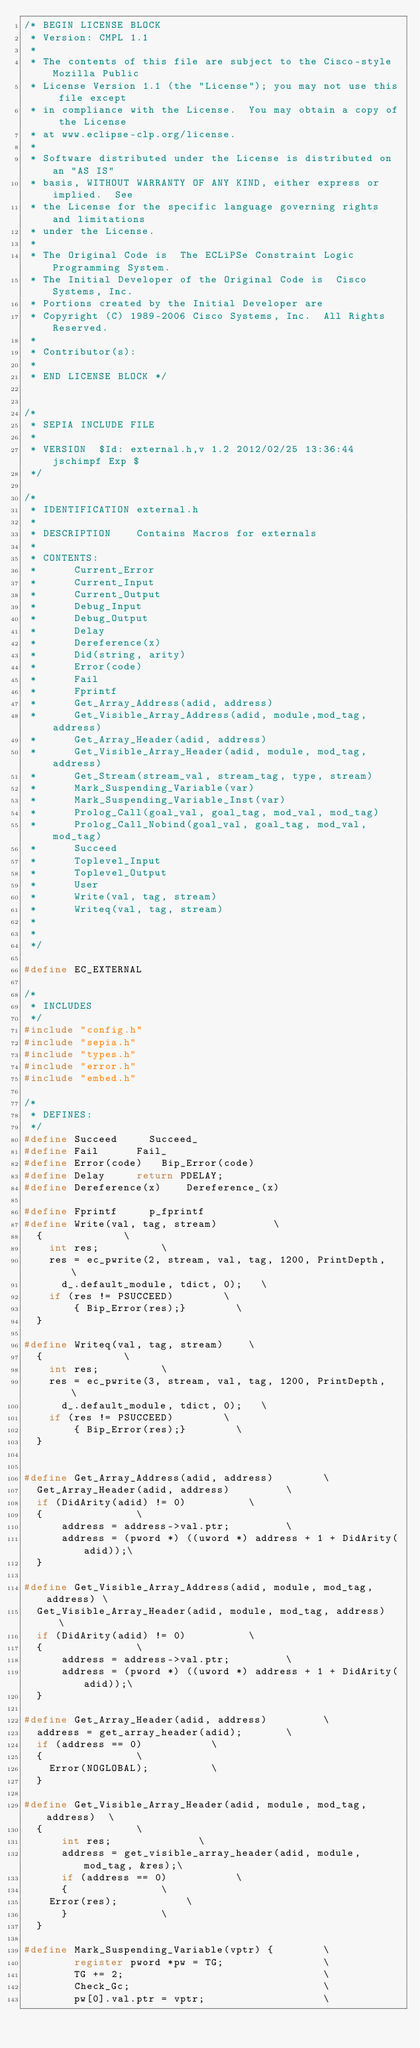<code> <loc_0><loc_0><loc_500><loc_500><_C_>/* BEGIN LICENSE BLOCK
 * Version: CMPL 1.1
 *
 * The contents of this file are subject to the Cisco-style Mozilla Public
 * License Version 1.1 (the "License"); you may not use this file except
 * in compliance with the License.  You may obtain a copy of the License
 * at www.eclipse-clp.org/license.
 * 
 * Software distributed under the License is distributed on an "AS IS"
 * basis, WITHOUT WARRANTY OF ANY KIND, either express or implied.  See
 * the License for the specific language governing rights and limitations
 * under the License. 
 * 
 * The Original Code is  The ECLiPSe Constraint Logic Programming System. 
 * The Initial Developer of the Original Code is  Cisco Systems, Inc. 
 * Portions created by the Initial Developer are
 * Copyright (C) 1989-2006 Cisco Systems, Inc.  All Rights Reserved.
 * 
 * Contributor(s): 
 * 
 * END LICENSE BLOCK */


/*
 * SEPIA INCLUDE FILE
 *
 * VERSION	$Id: external.h,v 1.2 2012/02/25 13:36:44 jschimpf Exp $
 */

/*
 * IDENTIFICATION	external.h
 *
 * DESCRIPTION   	Contains Macros for externals 
 *       
 * CONTENTS:
 *			Current_Error 
 *			Current_Input  
 *			Current_Output 
 *			Debug_Input
 *			Debug_Output 
 *			Delay     
 *			Dereference(x) 
 *			Did(string, arity)  
 *			Error(code)  
 *			Fail  
 *			Fprintf  
 *			Get_Array_Address(adid, address)
 *			Get_Visible_Array_Address(adid, module,mod_tag,address)
 *			Get_Array_Header(adid, address)  
 *			Get_Visible_Array_Header(adid, module, mod_tag,address)
 *			Get_Stream(stream_val, stream_tag, type, stream)
 *			Mark_Suspending_Variable(var)
 *			Mark_Suspending_Variable_Inst(var)
 *			Prolog_Call(goal_val, goal_tag, mod_val, mod_tag)
 *			Prolog_Call_Nobind(goal_val, goal_tag, mod_val, mod_tag)
 *			Succeed  
 *			Toplevel_Input  
 *			Toplevel_Output  
 *			User 
 *			Write(val, tag, stream)  
 *			Writeq(val, tag, stream) 
 *
 *
 */

#define EC_EXTERNAL

/*
 * INCLUDES
 */
#include "config.h"
#include "sepia.h"
#include "types.h"
#include "error.h"
#include "embed.h"

/*
 * DEFINES:
 */
#define	Succeed			Succeed_
#define Fail			Fail_
#define Error(code)		Bip_Error(code)
#define Delay			return PDELAY;
#define Dereference(x)		Dereference_(x)

#define Fprintf			p_fprintf
#define Write(val, tag, stream)					\
	{							\
		int	res;					\
		res = ec_pwrite(2, stream, val, tag, 1200, PrintDepth,	\
			d_.default_module, tdict, 0);		\
		if (res != PSUCCEED)				\
		    { Bip_Error(res);}				\
	}

#define Writeq(val, tag, stream)		\
	{							\
		int	res;					\
		res = ec_pwrite(3, stream, val, tag, 1200, PrintDepth,	\
			d_.default_module, tdict, 0);		\
		if (res != PSUCCEED)				\
		    { Bip_Error(res);}				\
	}


#define Get_Array_Address(adid, address)				\
	Get_Array_Header(adid, address)					\
	if (DidArity(adid) != 0)					\
	{								\
	    address = address->val.ptr;					\
	    address = (pword *) ((uword *) address + 1 + DidArity(adid));\
	}

#define Get_Visible_Array_Address(adid, module, mod_tag, address)	\
	Get_Visible_Array_Header(adid, module, mod_tag, address)	\
	if (DidArity(adid) != 0)					\
	{								\
	    address = address->val.ptr;					\
	    address = (pword *) ((uword *) address + 1 + DidArity(adid));\
	}

#define Get_Array_Header(adid, address)					\
	address = get_array_header(adid);				\
	if (address == 0)						\
	{								\
		Error(NOGLOBAL);					\
	}

#define Get_Visible_Array_Header(adid, module, mod_tag, address)	\
	{								\
	    int	res;							\
	    address = get_visible_array_header(adid, module, mod_tag, &res);\
	    if (address == 0)						\
	    {								\
		Error(res);						\
	    }								\
	}

#define Mark_Suspending_Variable(vptr) {        \
        register pword *pw = TG;                \
        TG += 2;                                \
        Check_Gc;                               \
        pw[0].val.ptr = vptr;                   \</code> 